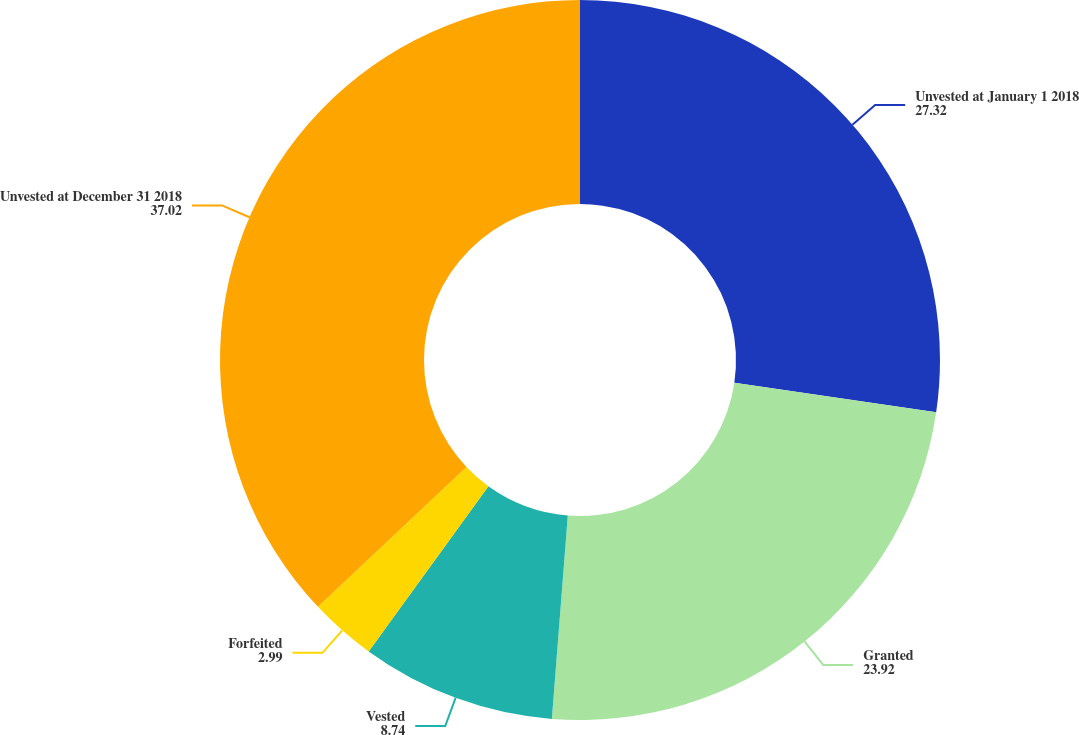Convert chart. <chart><loc_0><loc_0><loc_500><loc_500><pie_chart><fcel>Unvested at January 1 2018<fcel>Granted<fcel>Vested<fcel>Forfeited<fcel>Unvested at December 31 2018<nl><fcel>27.32%<fcel>23.92%<fcel>8.74%<fcel>2.99%<fcel>37.02%<nl></chart> 